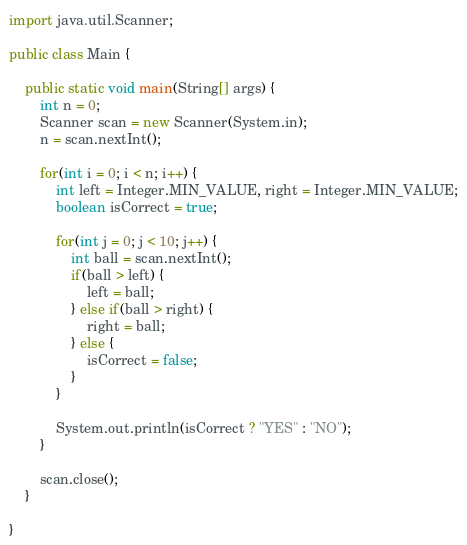<code> <loc_0><loc_0><loc_500><loc_500><_Java_>import java.util.Scanner;

public class Main {

	public static void main(String[] args) {
		int n = 0;
		Scanner scan = new Scanner(System.in);
		n = scan.nextInt();

		for(int i = 0; i < n; i++) {
			int left = Integer.MIN_VALUE, right = Integer.MIN_VALUE;
			boolean isCorrect = true;

			for(int j = 0; j < 10; j++) {
				int ball = scan.nextInt();
				if(ball > left) {
					left = ball;
				} else if(ball > right) {
					right = ball;
				} else {
					isCorrect = false;
				}
			}

			System.out.println(isCorrect ? "YES" : "NO");
		}

		scan.close();
	}

}
</code> 